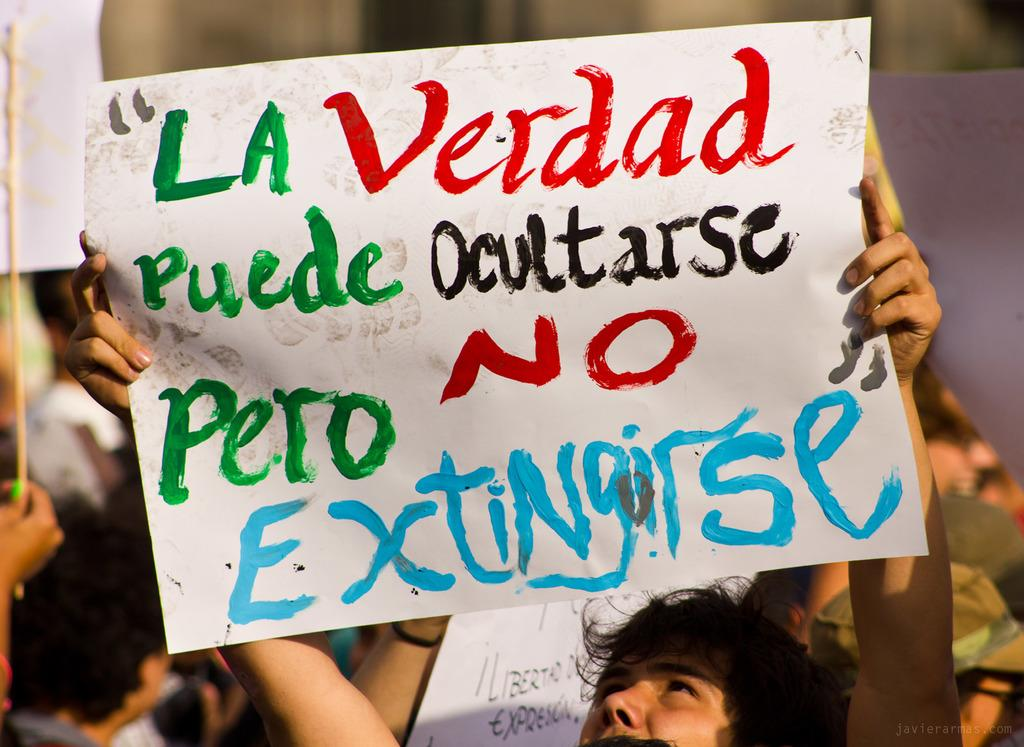Who is the main subject in the image? There is a man in the image. What is the man holding in the image? The man is holding a poster. What can be seen on the poster? The poster has text on it. What is visible in the background of the image? There are people, posters, and sticks in the background of the image. What type of notebook is the man using to write on the poster in the image? There is no notebook present in the image, and the man is not writing on the poster. 